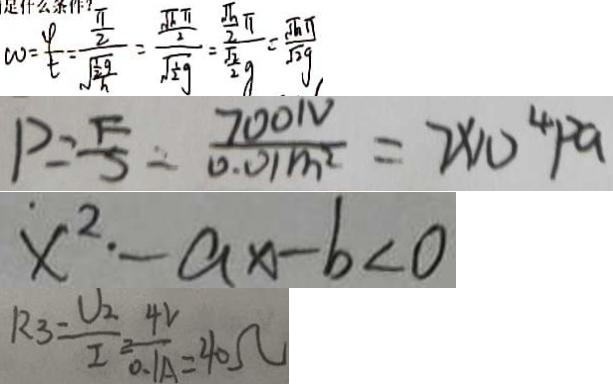Convert formula to latex. <formula><loc_0><loc_0><loc_500><loc_500>w = \frac { \varphi } { t } = \frac { \frac { \pi } { 2 } } { \sqrt { \frac { \frac { 1 } { 2 } g } { h } } } = \frac { \frac { \sqrt { h } \pi } { 2 } } { \sqrt { \frac { 1 } { 2 } g } } = \frac { \frac { \sqrt { h } } { 2 } \pi } { \frac { \sqrt { 2 } } { 2 } g } = \frac { \sqrt { h } \pi } { \sqrt { 2 } g } 
 P = \frac { F } { S } = \frac { 7 0 0 N } { 0 . 0 1 m ^ { 2 } } = 7 \times 1 0 ^ { 4 } P a 
 x ^ { 2 } \cdot - a x - b < 0 
 R _ { 3 } = \frac { U _ { 2 } } { I _ { 2 } } = \frac { 4 V } { 0 . 1 A } = 4 0 \Omega</formula> 